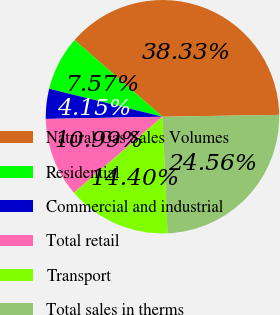<chart> <loc_0><loc_0><loc_500><loc_500><pie_chart><fcel>Natural Gas Sales Volumes<fcel>Residential<fcel>Commercial and industrial<fcel>Total retail<fcel>Transport<fcel>Total sales in therms<nl><fcel>38.33%<fcel>7.57%<fcel>4.15%<fcel>10.99%<fcel>14.4%<fcel>24.56%<nl></chart> 